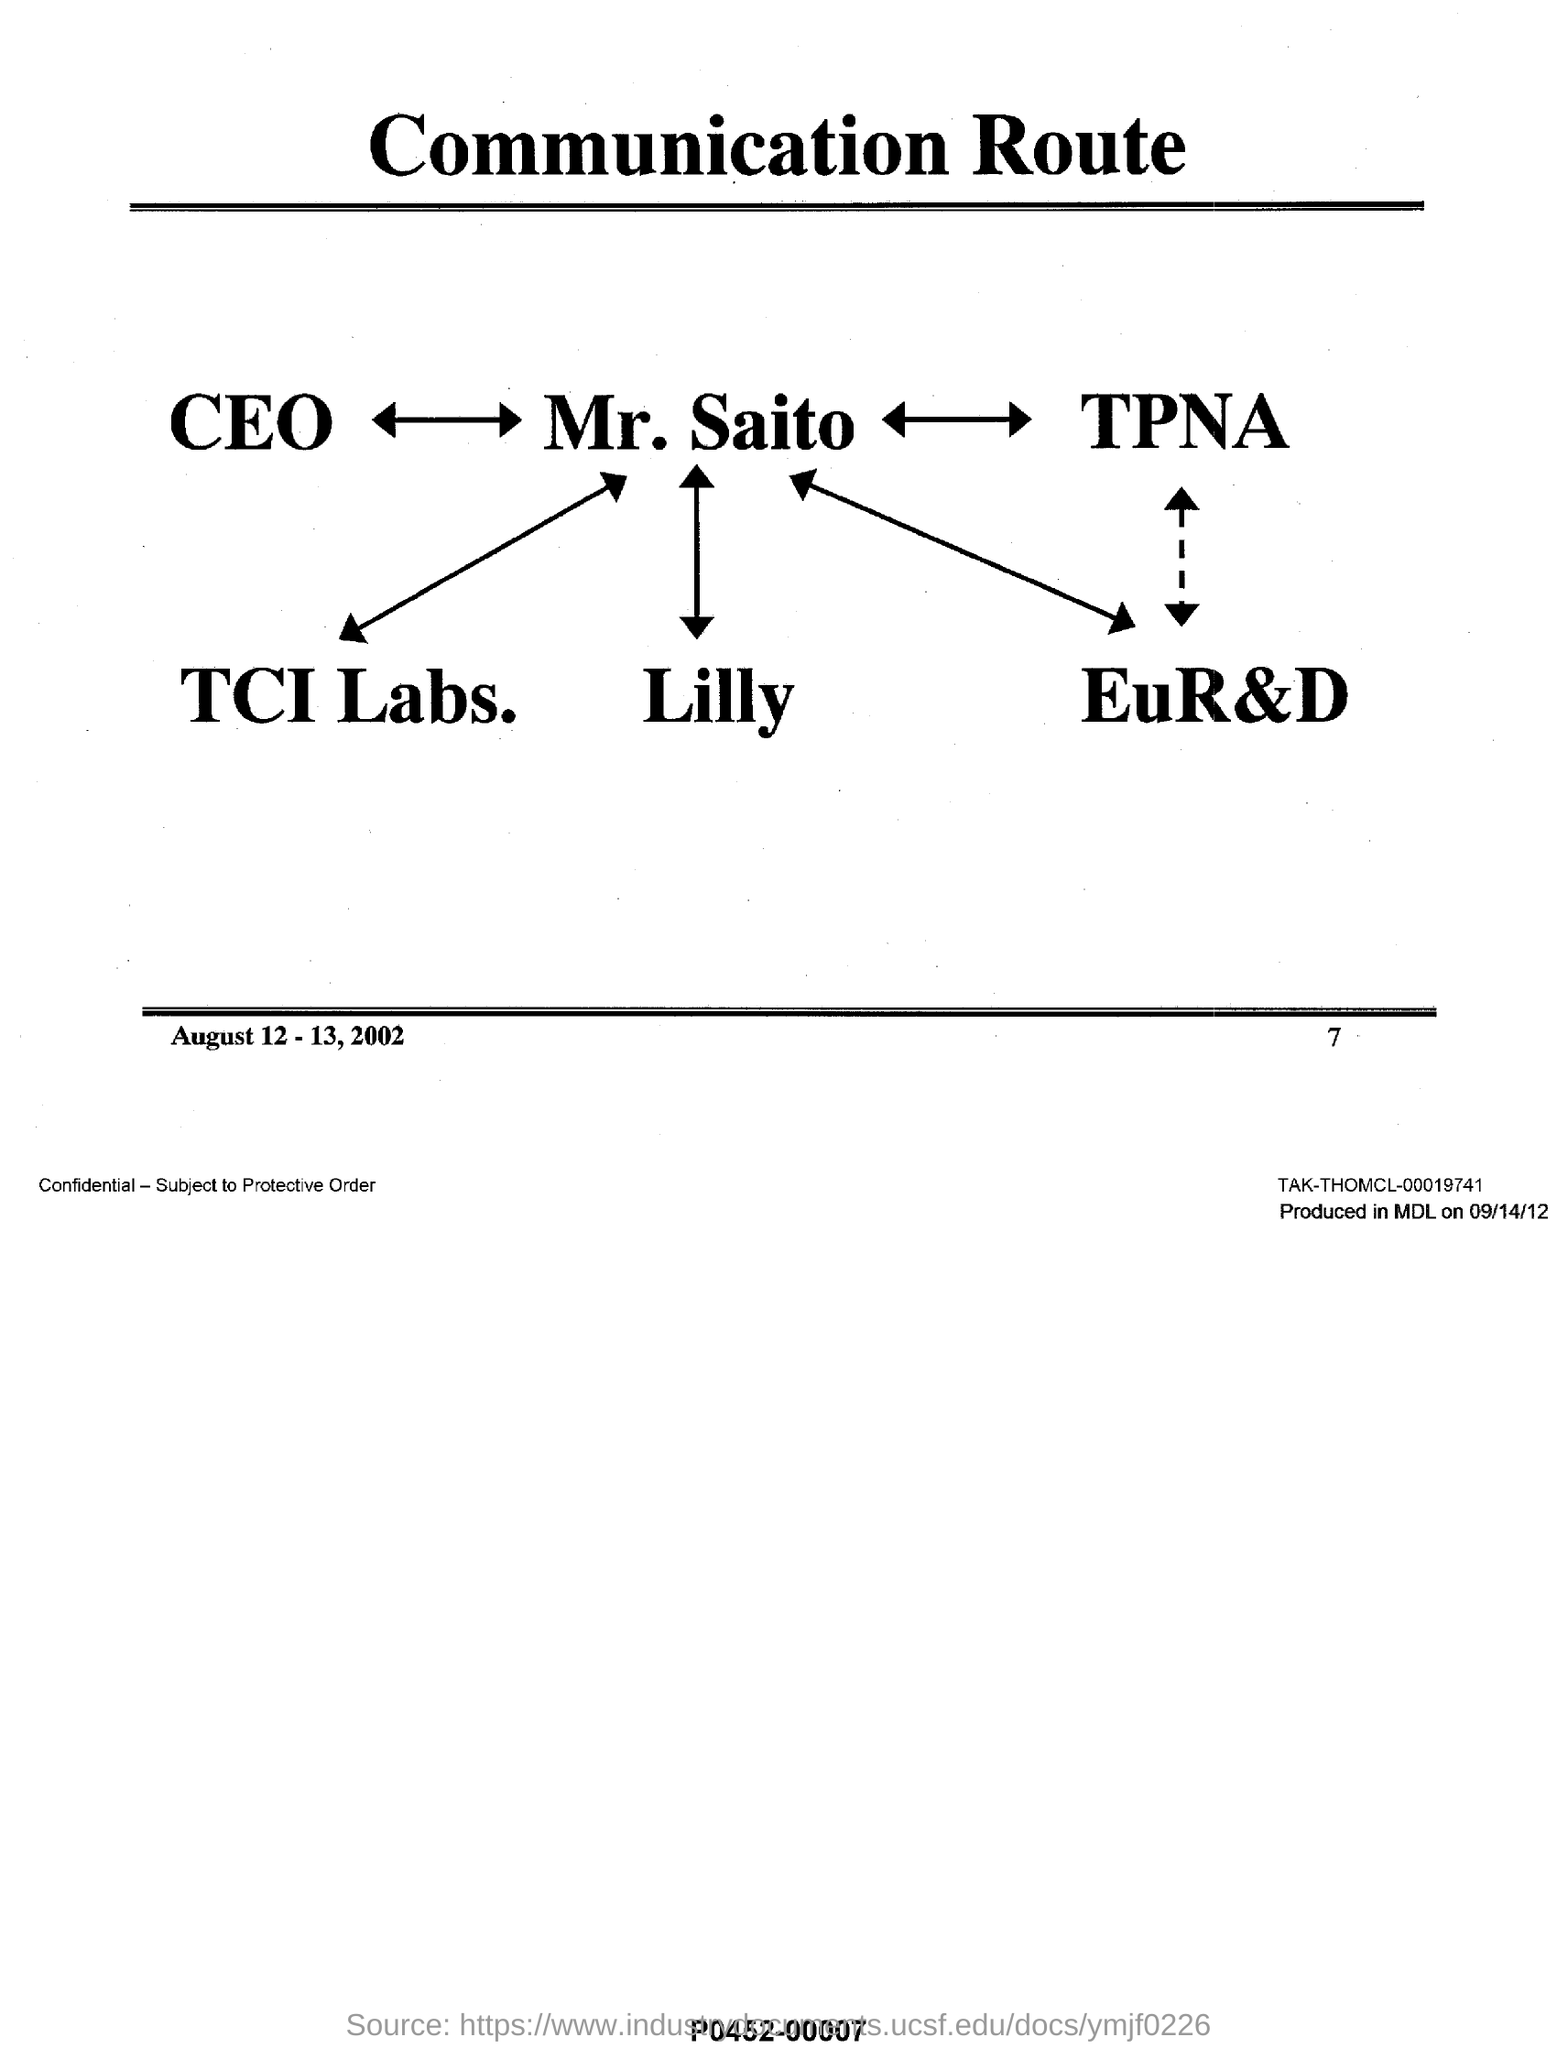Mention a couple of crucial points in this snapshot. What is the title of this document? It is called 'Communication Route..' The date range mentioned in this document at the bottom is August 12 and August 13, 2002. The page number mentioned in this document is 7. 